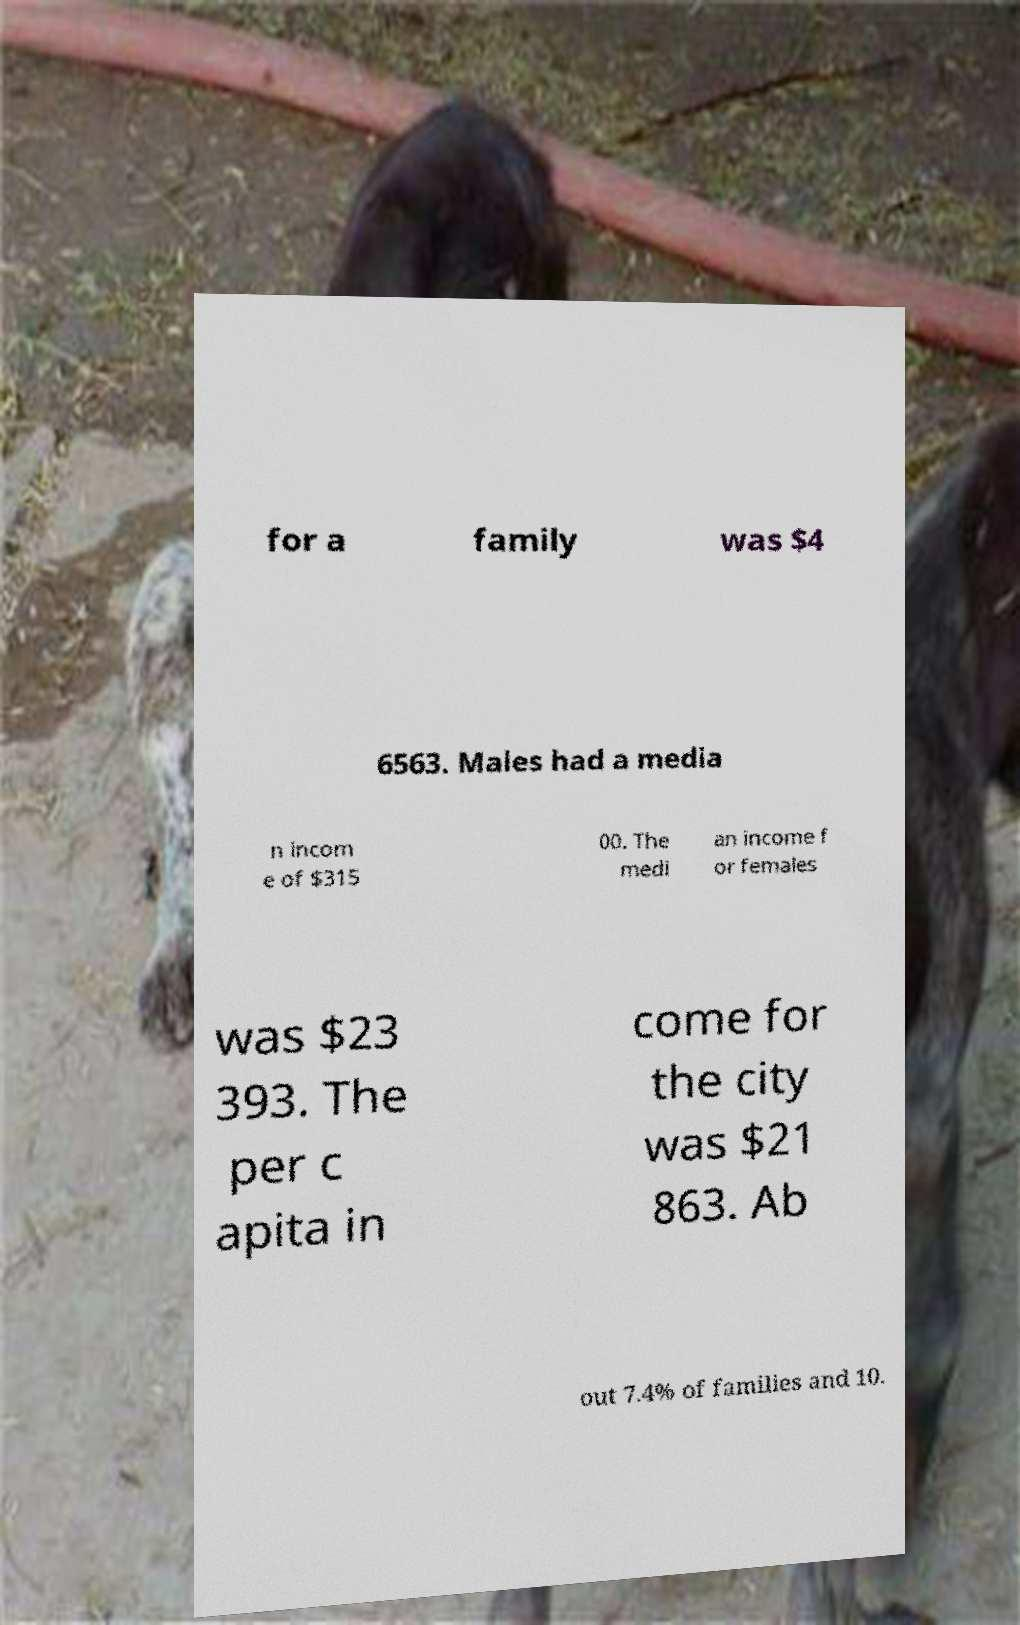Could you assist in decoding the text presented in this image and type it out clearly? for a family was $4 6563. Males had a media n incom e of $315 00. The medi an income f or females was $23 393. The per c apita in come for the city was $21 863. Ab out 7.4% of families and 10. 